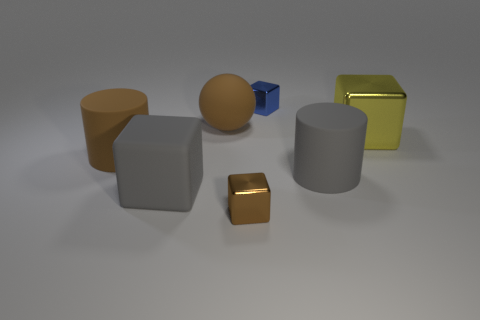Subtract all small brown metallic cubes. How many cubes are left? 3 Add 1 big green rubber balls. How many objects exist? 8 Subtract all gray blocks. How many blocks are left? 3 Subtract all cylinders. How many objects are left? 5 Subtract all purple blocks. Subtract all blue cylinders. How many blocks are left? 4 Subtract all large balls. Subtract all blue things. How many objects are left? 5 Add 2 metal cubes. How many metal cubes are left? 5 Add 6 blue spheres. How many blue spheres exist? 6 Subtract 0 cyan cubes. How many objects are left? 7 